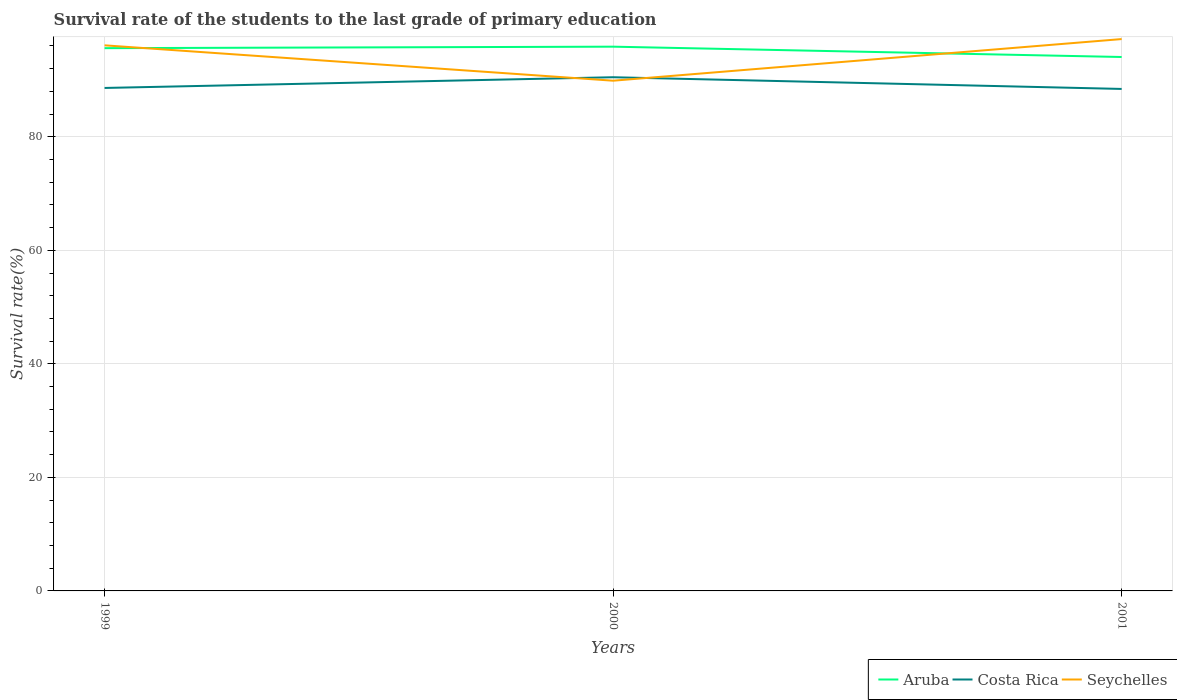How many different coloured lines are there?
Provide a short and direct response. 3. Does the line corresponding to Costa Rica intersect with the line corresponding to Seychelles?
Your response must be concise. Yes. Across all years, what is the maximum survival rate of the students in Costa Rica?
Give a very brief answer. 88.42. What is the total survival rate of the students in Aruba in the graph?
Offer a very short reply. -0.26. What is the difference between the highest and the second highest survival rate of the students in Costa Rica?
Keep it short and to the point. 2.06. Is the survival rate of the students in Costa Rica strictly greater than the survival rate of the students in Seychelles over the years?
Keep it short and to the point. No. How many lines are there?
Keep it short and to the point. 3. What is the difference between two consecutive major ticks on the Y-axis?
Your answer should be compact. 20. Are the values on the major ticks of Y-axis written in scientific E-notation?
Provide a short and direct response. No. Does the graph contain any zero values?
Provide a succinct answer. No. Does the graph contain grids?
Make the answer very short. Yes. What is the title of the graph?
Make the answer very short. Survival rate of the students to the last grade of primary education. What is the label or title of the Y-axis?
Offer a terse response. Survival rate(%). What is the Survival rate(%) in Aruba in 1999?
Offer a terse response. 95.61. What is the Survival rate(%) in Costa Rica in 1999?
Your answer should be compact. 88.6. What is the Survival rate(%) in Seychelles in 1999?
Your response must be concise. 96.1. What is the Survival rate(%) in Aruba in 2000?
Provide a succinct answer. 95.87. What is the Survival rate(%) in Costa Rica in 2000?
Offer a terse response. 90.48. What is the Survival rate(%) of Seychelles in 2000?
Provide a short and direct response. 89.87. What is the Survival rate(%) in Aruba in 2001?
Offer a terse response. 94.05. What is the Survival rate(%) in Costa Rica in 2001?
Provide a succinct answer. 88.42. What is the Survival rate(%) of Seychelles in 2001?
Offer a very short reply. 97.21. Across all years, what is the maximum Survival rate(%) of Aruba?
Provide a succinct answer. 95.87. Across all years, what is the maximum Survival rate(%) in Costa Rica?
Offer a very short reply. 90.48. Across all years, what is the maximum Survival rate(%) of Seychelles?
Give a very brief answer. 97.21. Across all years, what is the minimum Survival rate(%) of Aruba?
Provide a short and direct response. 94.05. Across all years, what is the minimum Survival rate(%) of Costa Rica?
Your answer should be very brief. 88.42. Across all years, what is the minimum Survival rate(%) of Seychelles?
Offer a terse response. 89.87. What is the total Survival rate(%) in Aruba in the graph?
Your answer should be compact. 285.52. What is the total Survival rate(%) of Costa Rica in the graph?
Provide a short and direct response. 267.5. What is the total Survival rate(%) of Seychelles in the graph?
Offer a very short reply. 283.19. What is the difference between the Survival rate(%) of Aruba in 1999 and that in 2000?
Offer a very short reply. -0.26. What is the difference between the Survival rate(%) of Costa Rica in 1999 and that in 2000?
Your answer should be compact. -1.89. What is the difference between the Survival rate(%) of Seychelles in 1999 and that in 2000?
Provide a short and direct response. 6.23. What is the difference between the Survival rate(%) in Aruba in 1999 and that in 2001?
Your answer should be very brief. 1.56. What is the difference between the Survival rate(%) in Costa Rica in 1999 and that in 2001?
Make the answer very short. 0.17. What is the difference between the Survival rate(%) of Seychelles in 1999 and that in 2001?
Offer a terse response. -1.1. What is the difference between the Survival rate(%) in Aruba in 2000 and that in 2001?
Ensure brevity in your answer.  1.82. What is the difference between the Survival rate(%) in Costa Rica in 2000 and that in 2001?
Ensure brevity in your answer.  2.06. What is the difference between the Survival rate(%) of Seychelles in 2000 and that in 2001?
Keep it short and to the point. -7.33. What is the difference between the Survival rate(%) of Aruba in 1999 and the Survival rate(%) of Costa Rica in 2000?
Provide a succinct answer. 5.12. What is the difference between the Survival rate(%) of Aruba in 1999 and the Survival rate(%) of Seychelles in 2000?
Give a very brief answer. 5.73. What is the difference between the Survival rate(%) of Costa Rica in 1999 and the Survival rate(%) of Seychelles in 2000?
Keep it short and to the point. -1.28. What is the difference between the Survival rate(%) in Aruba in 1999 and the Survival rate(%) in Costa Rica in 2001?
Keep it short and to the point. 7.18. What is the difference between the Survival rate(%) in Aruba in 1999 and the Survival rate(%) in Seychelles in 2001?
Your answer should be compact. -1.6. What is the difference between the Survival rate(%) in Costa Rica in 1999 and the Survival rate(%) in Seychelles in 2001?
Your answer should be very brief. -8.61. What is the difference between the Survival rate(%) of Aruba in 2000 and the Survival rate(%) of Costa Rica in 2001?
Offer a very short reply. 7.45. What is the difference between the Survival rate(%) in Aruba in 2000 and the Survival rate(%) in Seychelles in 2001?
Ensure brevity in your answer.  -1.34. What is the difference between the Survival rate(%) of Costa Rica in 2000 and the Survival rate(%) of Seychelles in 2001?
Give a very brief answer. -6.72. What is the average Survival rate(%) in Aruba per year?
Make the answer very short. 95.17. What is the average Survival rate(%) in Costa Rica per year?
Your response must be concise. 89.17. What is the average Survival rate(%) of Seychelles per year?
Ensure brevity in your answer.  94.4. In the year 1999, what is the difference between the Survival rate(%) of Aruba and Survival rate(%) of Costa Rica?
Provide a short and direct response. 7.01. In the year 1999, what is the difference between the Survival rate(%) in Aruba and Survival rate(%) in Seychelles?
Ensure brevity in your answer.  -0.5. In the year 1999, what is the difference between the Survival rate(%) in Costa Rica and Survival rate(%) in Seychelles?
Keep it short and to the point. -7.51. In the year 2000, what is the difference between the Survival rate(%) of Aruba and Survival rate(%) of Costa Rica?
Your response must be concise. 5.38. In the year 2000, what is the difference between the Survival rate(%) in Aruba and Survival rate(%) in Seychelles?
Ensure brevity in your answer.  6. In the year 2000, what is the difference between the Survival rate(%) of Costa Rica and Survival rate(%) of Seychelles?
Ensure brevity in your answer.  0.61. In the year 2001, what is the difference between the Survival rate(%) of Aruba and Survival rate(%) of Costa Rica?
Provide a succinct answer. 5.63. In the year 2001, what is the difference between the Survival rate(%) in Aruba and Survival rate(%) in Seychelles?
Your answer should be very brief. -3.16. In the year 2001, what is the difference between the Survival rate(%) in Costa Rica and Survival rate(%) in Seychelles?
Keep it short and to the point. -8.79. What is the ratio of the Survival rate(%) in Aruba in 1999 to that in 2000?
Provide a short and direct response. 1. What is the ratio of the Survival rate(%) of Costa Rica in 1999 to that in 2000?
Your answer should be very brief. 0.98. What is the ratio of the Survival rate(%) in Seychelles in 1999 to that in 2000?
Provide a short and direct response. 1.07. What is the ratio of the Survival rate(%) of Aruba in 1999 to that in 2001?
Your response must be concise. 1.02. What is the ratio of the Survival rate(%) of Costa Rica in 1999 to that in 2001?
Your response must be concise. 1. What is the ratio of the Survival rate(%) in Seychelles in 1999 to that in 2001?
Give a very brief answer. 0.99. What is the ratio of the Survival rate(%) in Aruba in 2000 to that in 2001?
Your answer should be compact. 1.02. What is the ratio of the Survival rate(%) of Costa Rica in 2000 to that in 2001?
Keep it short and to the point. 1.02. What is the ratio of the Survival rate(%) in Seychelles in 2000 to that in 2001?
Ensure brevity in your answer.  0.92. What is the difference between the highest and the second highest Survival rate(%) in Aruba?
Your response must be concise. 0.26. What is the difference between the highest and the second highest Survival rate(%) of Costa Rica?
Give a very brief answer. 1.89. What is the difference between the highest and the second highest Survival rate(%) in Seychelles?
Make the answer very short. 1.1. What is the difference between the highest and the lowest Survival rate(%) of Aruba?
Ensure brevity in your answer.  1.82. What is the difference between the highest and the lowest Survival rate(%) in Costa Rica?
Your answer should be very brief. 2.06. What is the difference between the highest and the lowest Survival rate(%) of Seychelles?
Ensure brevity in your answer.  7.33. 